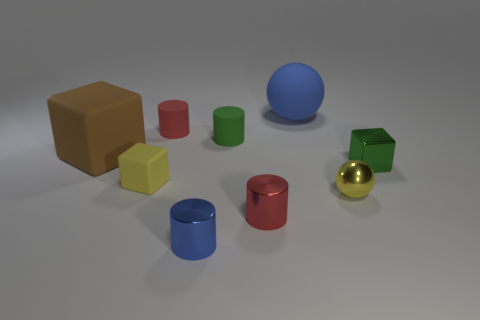Subtract all cylinders. How many objects are left? 5 Add 4 small matte blocks. How many small matte blocks are left? 5 Add 6 large green matte balls. How many large green matte balls exist? 6 Subtract 1 blue balls. How many objects are left? 8 Subtract all small blue cylinders. Subtract all small cylinders. How many objects are left? 4 